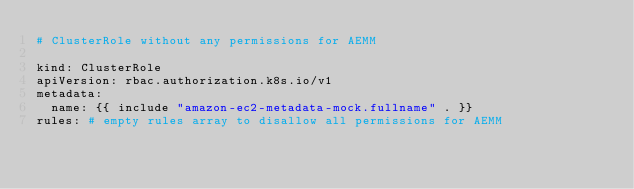<code> <loc_0><loc_0><loc_500><loc_500><_YAML_># ClusterRole without any permissions for AEMM

kind: ClusterRole
apiVersion: rbac.authorization.k8s.io/v1
metadata:
  name: {{ include "amazon-ec2-metadata-mock.fullname" . }}
rules: # empty rules array to disallow all permissions for AEMM </code> 